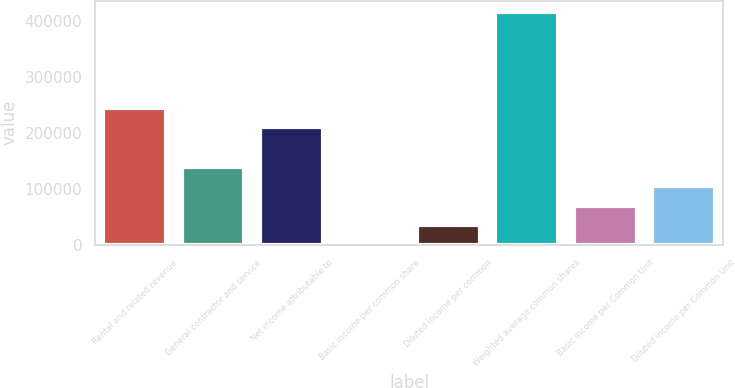Convert chart to OTSL. <chart><loc_0><loc_0><loc_500><loc_500><bar_chart><fcel>Rental and related revenue<fcel>General contractor and service<fcel>Net income attributable to<fcel>Basic income per common share<fcel>Diluted income per common<fcel>Weighted average common shares<fcel>Basic income per Common Unit<fcel>Diluted income per Common Unit<nl><fcel>244772<fcel>139870<fcel>209804<fcel>0.12<fcel>34967.5<fcel>415600<fcel>69934.9<fcel>104902<nl></chart> 